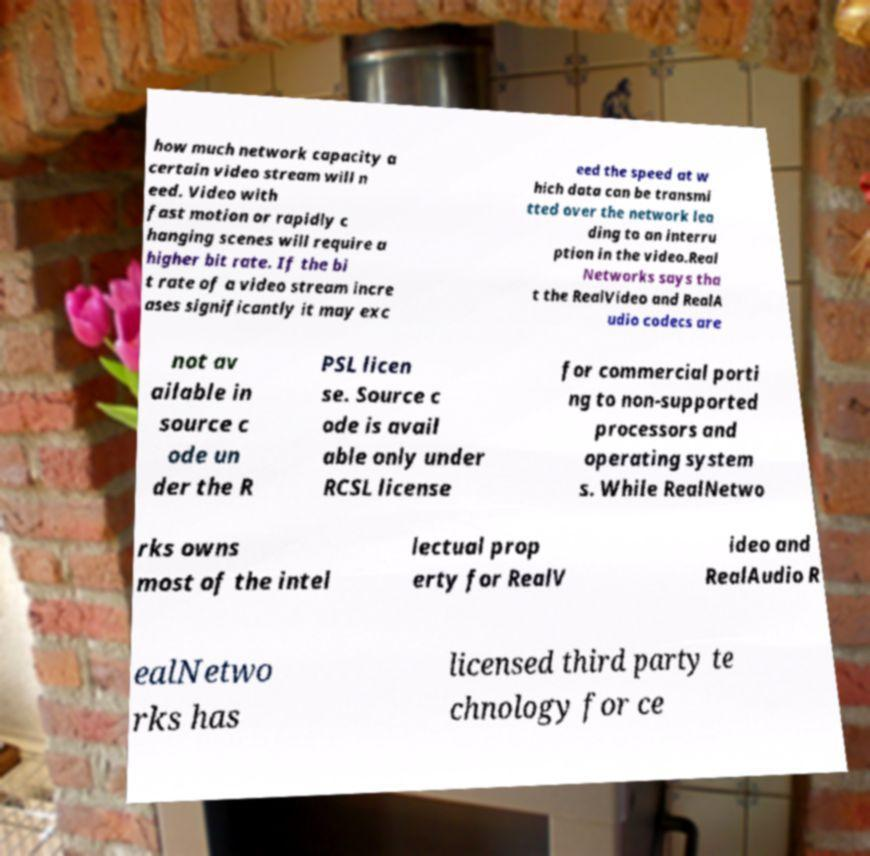For documentation purposes, I need the text within this image transcribed. Could you provide that? how much network capacity a certain video stream will n eed. Video with fast motion or rapidly c hanging scenes will require a higher bit rate. If the bi t rate of a video stream incre ases significantly it may exc eed the speed at w hich data can be transmi tted over the network lea ding to an interru ption in the video.Real Networks says tha t the RealVideo and RealA udio codecs are not av ailable in source c ode un der the R PSL licen se. Source c ode is avail able only under RCSL license for commercial porti ng to non-supported processors and operating system s. While RealNetwo rks owns most of the intel lectual prop erty for RealV ideo and RealAudio R ealNetwo rks has licensed third party te chnology for ce 